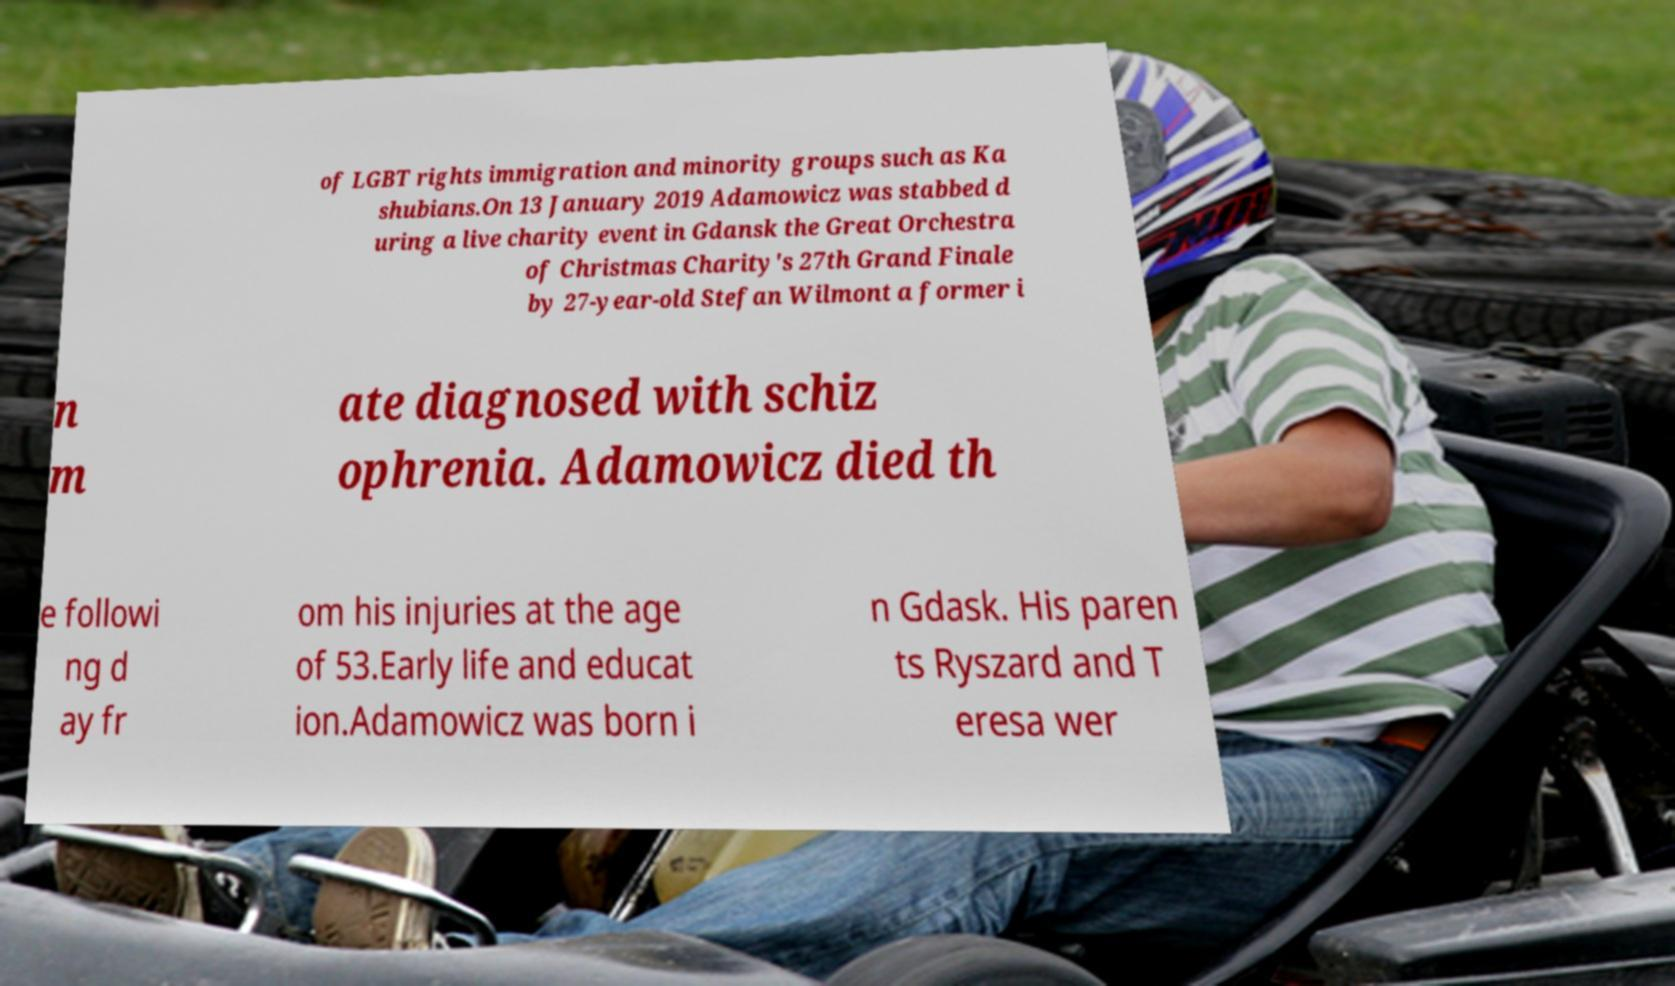For documentation purposes, I need the text within this image transcribed. Could you provide that? of LGBT rights immigration and minority groups such as Ka shubians.On 13 January 2019 Adamowicz was stabbed d uring a live charity event in Gdansk the Great Orchestra of Christmas Charity's 27th Grand Finale by 27-year-old Stefan Wilmont a former i n m ate diagnosed with schiz ophrenia. Adamowicz died th e followi ng d ay fr om his injuries at the age of 53.Early life and educat ion.Adamowicz was born i n Gdask. His paren ts Ryszard and T eresa wer 